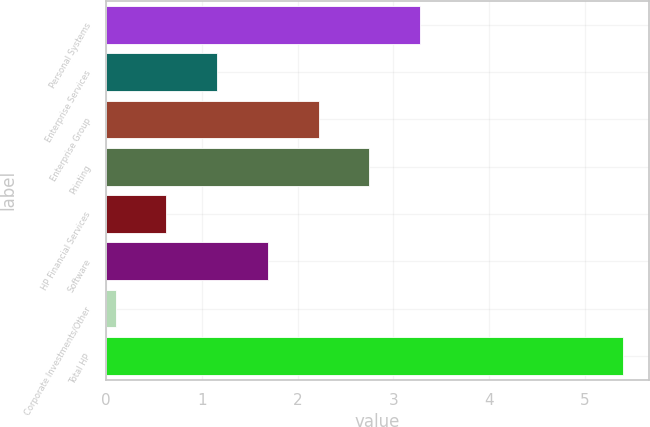<chart> <loc_0><loc_0><loc_500><loc_500><bar_chart><fcel>Personal Systems<fcel>Enterprise Services<fcel>Enterprise Group<fcel>Printing<fcel>HP Financial Services<fcel>Software<fcel>Corporate Investments/Other<fcel>Total HP<nl><fcel>3.28<fcel>1.16<fcel>2.22<fcel>2.75<fcel>0.63<fcel>1.69<fcel>0.1<fcel>5.4<nl></chart> 